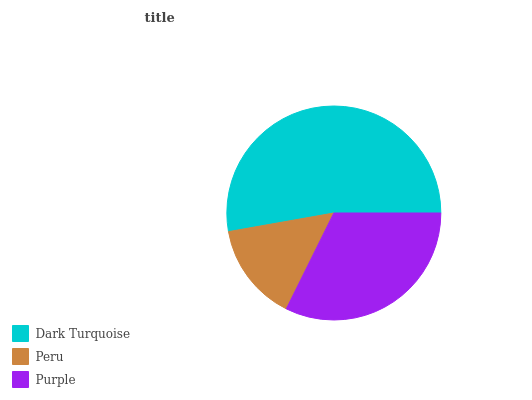Is Peru the minimum?
Answer yes or no. Yes. Is Dark Turquoise the maximum?
Answer yes or no. Yes. Is Purple the minimum?
Answer yes or no. No. Is Purple the maximum?
Answer yes or no. No. Is Purple greater than Peru?
Answer yes or no. Yes. Is Peru less than Purple?
Answer yes or no. Yes. Is Peru greater than Purple?
Answer yes or no. No. Is Purple less than Peru?
Answer yes or no. No. Is Purple the high median?
Answer yes or no. Yes. Is Purple the low median?
Answer yes or no. Yes. Is Dark Turquoise the high median?
Answer yes or no. No. Is Dark Turquoise the low median?
Answer yes or no. No. 